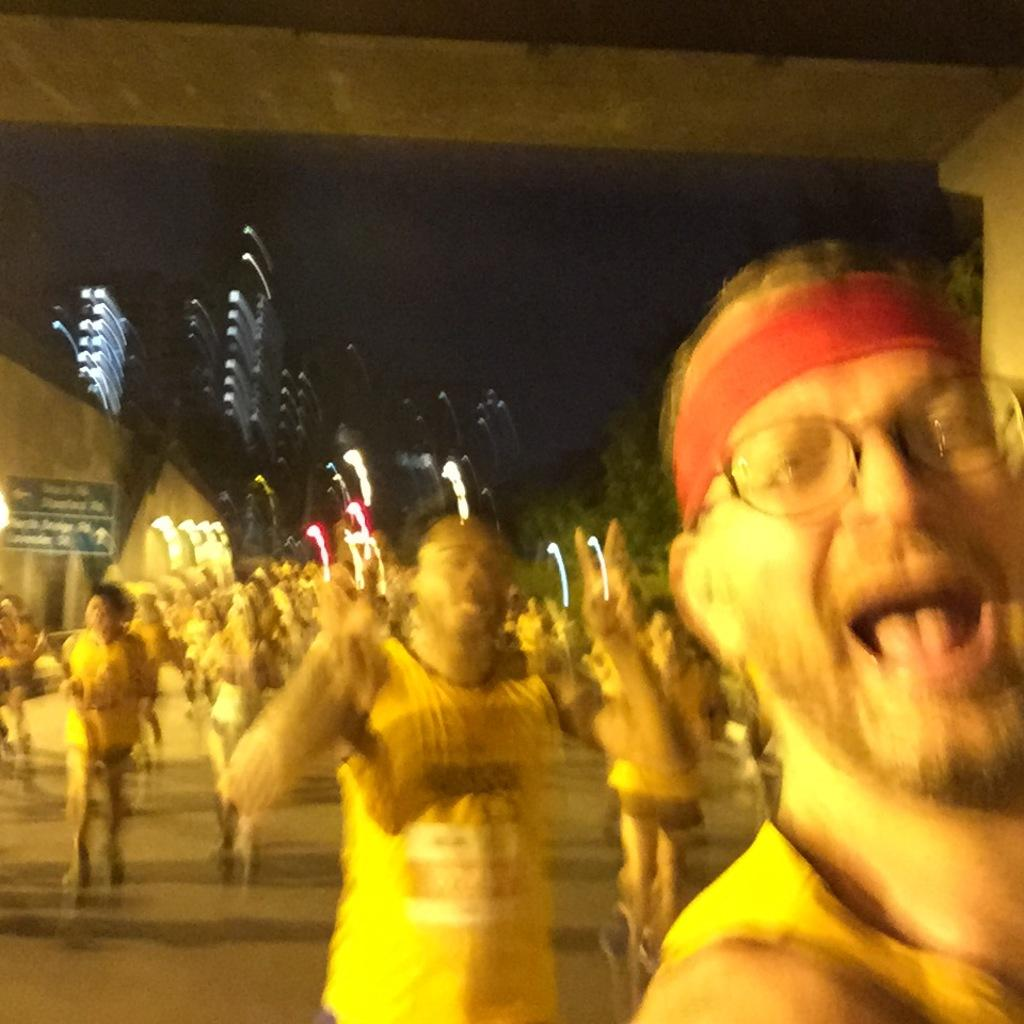What can be seen in the image? There are people standing in the image. What else is visible in the image besides the people? There are lights and trees visible in the image. What type of tongue can be seen in the image? There is no tongue present in the image. What experiences do the people in the image have in common? We cannot determine the experiences of the people in the image based on the provided facts. What hobbies do the people in the image enjoy? We cannot determine the hobbies of the people in the image based on the provided facts. 